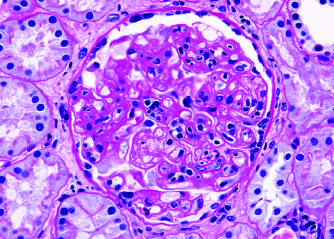what shows inflammatory cells within the capillary loops glomerulitis, accumulation of mesangial matrix, and duplication of the capillary basement membrane?
Answer the question using a single word or phrase. The glomerulus 